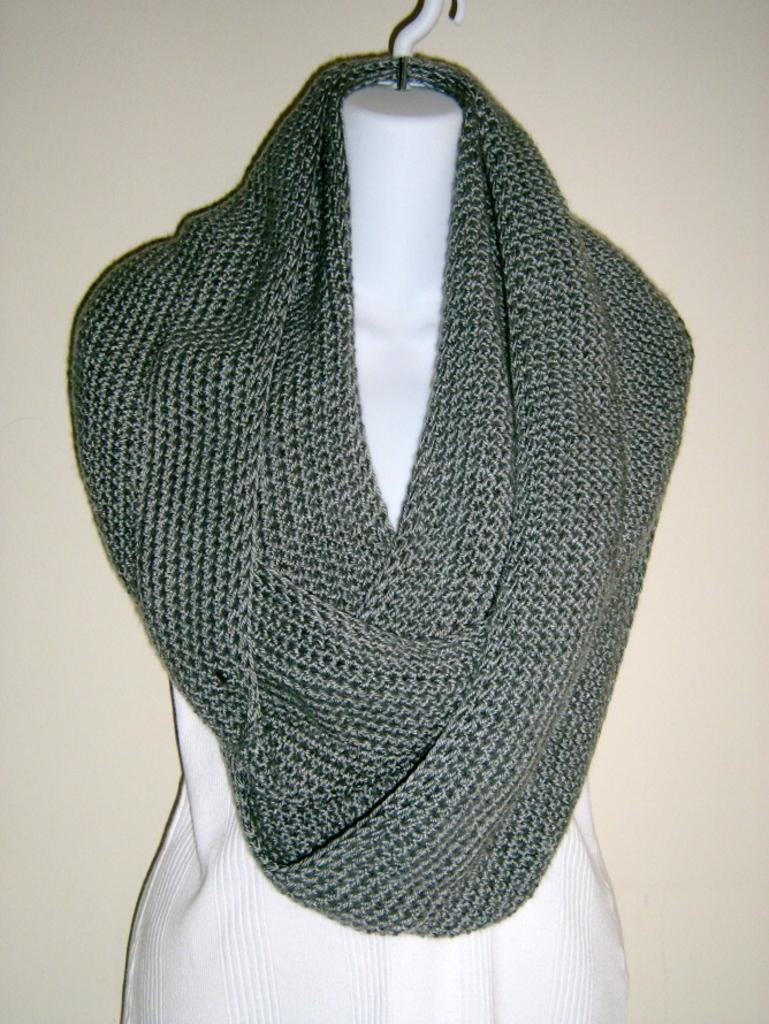What type of clothing item is in the image? There is a scarf and a dress in the image. How are the scarf and dress positioned in the image? Both the scarf and dress are on a hanger. What can be seen in the background of the image? There is a wall in the background of the image. What type of song is the farmer singing in the image? There is no farmer or song present in the image; it features a scarf and dress on a hanger with a wall in the background. 